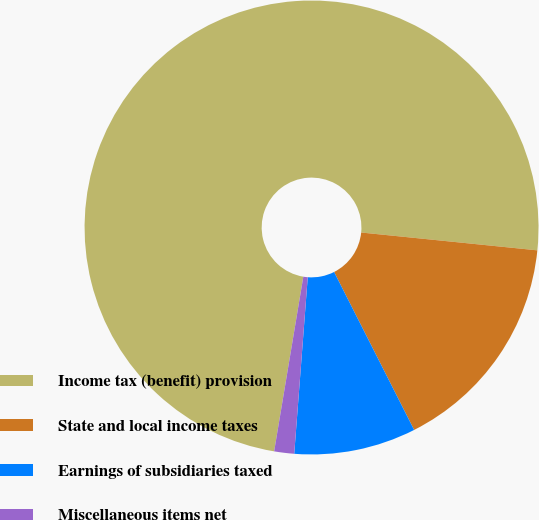Convert chart. <chart><loc_0><loc_0><loc_500><loc_500><pie_chart><fcel>Income tax (benefit) provision<fcel>State and local income taxes<fcel>Earnings of subsidiaries taxed<fcel>Miscellaneous items net<nl><fcel>73.97%<fcel>15.93%<fcel>8.68%<fcel>1.42%<nl></chart> 